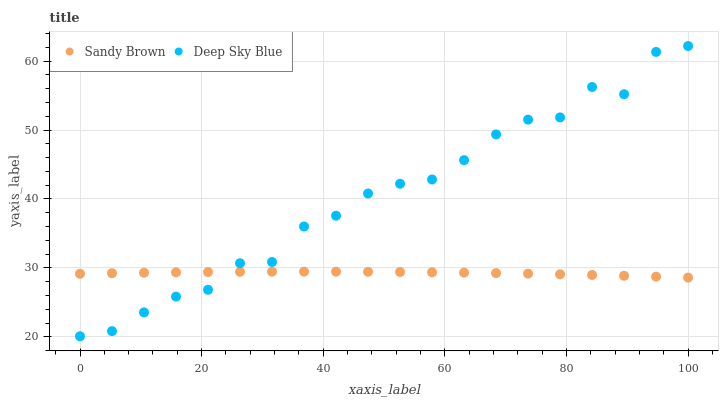Does Sandy Brown have the minimum area under the curve?
Answer yes or no. Yes. Does Deep Sky Blue have the maximum area under the curve?
Answer yes or no. Yes. Does Deep Sky Blue have the minimum area under the curve?
Answer yes or no. No. Is Sandy Brown the smoothest?
Answer yes or no. Yes. Is Deep Sky Blue the roughest?
Answer yes or no. Yes. Is Deep Sky Blue the smoothest?
Answer yes or no. No. Does Deep Sky Blue have the lowest value?
Answer yes or no. Yes. Does Deep Sky Blue have the highest value?
Answer yes or no. Yes. Does Sandy Brown intersect Deep Sky Blue?
Answer yes or no. Yes. Is Sandy Brown less than Deep Sky Blue?
Answer yes or no. No. Is Sandy Brown greater than Deep Sky Blue?
Answer yes or no. No. 